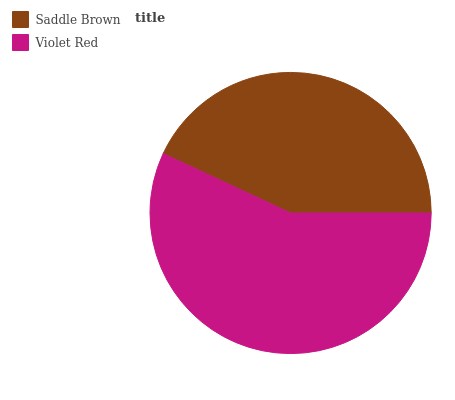Is Saddle Brown the minimum?
Answer yes or no. Yes. Is Violet Red the maximum?
Answer yes or no. Yes. Is Violet Red the minimum?
Answer yes or no. No. Is Violet Red greater than Saddle Brown?
Answer yes or no. Yes. Is Saddle Brown less than Violet Red?
Answer yes or no. Yes. Is Saddle Brown greater than Violet Red?
Answer yes or no. No. Is Violet Red less than Saddle Brown?
Answer yes or no. No. Is Violet Red the high median?
Answer yes or no. Yes. Is Saddle Brown the low median?
Answer yes or no. Yes. Is Saddle Brown the high median?
Answer yes or no. No. Is Violet Red the low median?
Answer yes or no. No. 